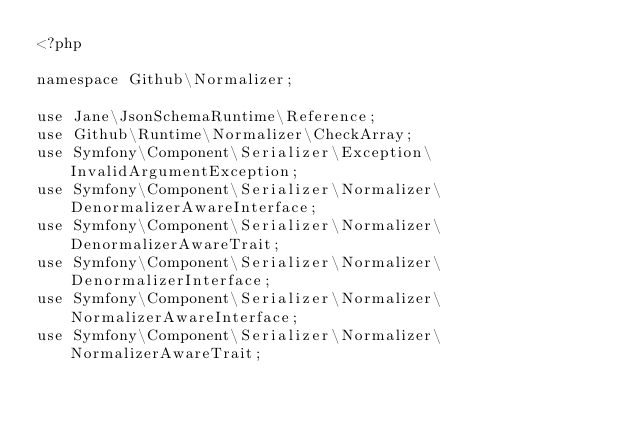Convert code to text. <code><loc_0><loc_0><loc_500><loc_500><_PHP_><?php

namespace Github\Normalizer;

use Jane\JsonSchemaRuntime\Reference;
use Github\Runtime\Normalizer\CheckArray;
use Symfony\Component\Serializer\Exception\InvalidArgumentException;
use Symfony\Component\Serializer\Normalizer\DenormalizerAwareInterface;
use Symfony\Component\Serializer\Normalizer\DenormalizerAwareTrait;
use Symfony\Component\Serializer\Normalizer\DenormalizerInterface;
use Symfony\Component\Serializer\Normalizer\NormalizerAwareInterface;
use Symfony\Component\Serializer\Normalizer\NormalizerAwareTrait;</code> 